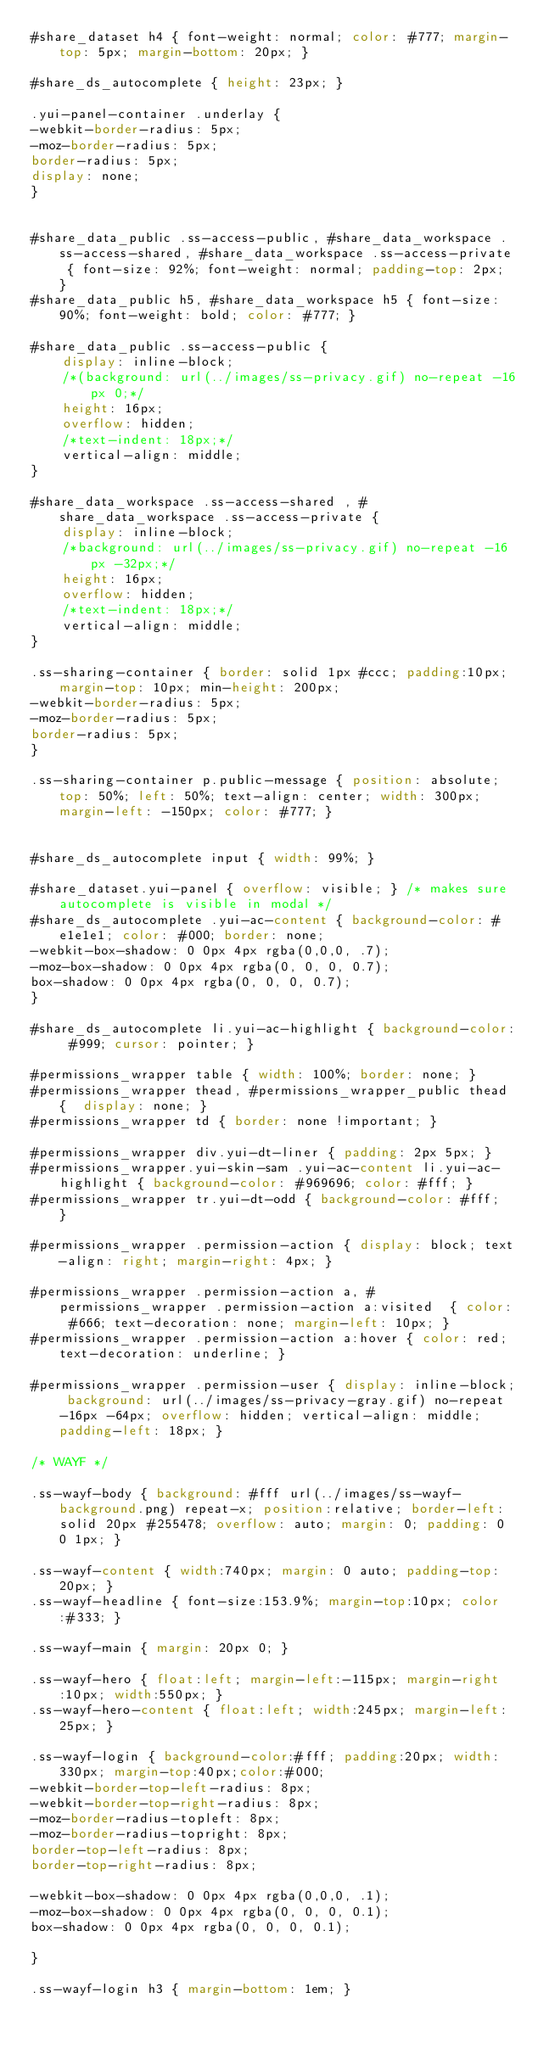<code> <loc_0><loc_0><loc_500><loc_500><_CSS_>#share_dataset h4 { font-weight: normal; color: #777; margin-top: 5px; margin-bottom: 20px; } 

#share_ds_autocomplete { height: 23px; }

.yui-panel-container .underlay {
-webkit-border-radius: 5px;
-moz-border-radius: 5px;
border-radius: 5px;
display: none;
}


#share_data_public .ss-access-public, #share_data_workspace .ss-access-shared, #share_data_workspace .ss-access-private { font-size: 92%; font-weight: normal; padding-top: 2px; }
#share_data_public h5, #share_data_workspace h5 { font-size: 90%; font-weight: bold; color: #777; }

#share_data_public .ss-access-public { 
    display: inline-block; 
    /*(background: url(../images/ss-privacy.gif) no-repeat -16px 0;*/
    height: 16px; 
    overflow: hidden; 
    /*text-indent: 18px;*/
    vertical-align: middle; 
}

#share_data_workspace .ss-access-shared , #share_data_workspace .ss-access-private { 
    display: inline-block; 
    /*background: url(../images/ss-privacy.gif) no-repeat -16px -32px;*/
    height: 16px; 
    overflow: hidden; 
    /*text-indent: 18px;*/
    vertical-align: middle; 
} 

.ss-sharing-container { border: solid 1px #ccc; padding:10px; margin-top: 10px; min-height: 200px;
-webkit-border-radius: 5px;
-moz-border-radius: 5px;
border-radius: 5px;
}

.ss-sharing-container p.public-message { position: absolute; top: 50%; left: 50%; text-align: center; width: 300px; margin-left: -150px; color: #777; }


#share_ds_autocomplete input { width: 99%; }

#share_dataset.yui-panel { overflow: visible; } /* makes sure autocomplete is visible in modal */
#share_ds_autocomplete .yui-ac-content { background-color: #e1e1e1; color: #000; border: none; 
-webkit-box-shadow: 0 0px 4px rgba(0,0,0, .7);
-moz-box-shadow: 0 0px 4px rgba(0, 0, 0, 0.7);
box-shadow: 0 0px 4px rgba(0, 0, 0, 0.7);
}

#share_ds_autocomplete li.yui-ac-highlight { background-color: #999; cursor: pointer; }

#permissions_wrapper table { width: 100%; border: none; }
#permissions_wrapper thead, #permissions_wrapper_public thead {  display: none; }
#permissions_wrapper td { border: none !important; } 

#permissions_wrapper div.yui-dt-liner { padding: 2px 5px; }
#permissions_wrapper.yui-skin-sam .yui-ac-content li.yui-ac-highlight { background-color: #969696; color: #fff; }
#permissions_wrapper tr.yui-dt-odd { background-color: #fff;  }

#permissions_wrapper .permission-action { display: block; text-align: right; margin-right: 4px; }

#permissions_wrapper .permission-action a, #permissions_wrapper .permission-action a:visited  { color: #666; text-decoration: none; margin-left: 10px; }
#permissions_wrapper .permission-action a:hover { color: red; text-decoration: underline; }

#permissions_wrapper .permission-user { display: inline-block; background: url(../images/ss-privacy-gray.gif) no-repeat -16px -64px; overflow: hidden; vertical-align: middle; padding-left: 18px; }

/* WAYF */

.ss-wayf-body { background: #fff url(../images/ss-wayf-background.png) repeat-x; position:relative; border-left: solid 20px #255478; overflow: auto; margin: 0; padding: 0 0 1px; }

.ss-wayf-content { width:740px; margin: 0 auto; padding-top: 20px; }
.ss-wayf-headline { font-size:153.9%; margin-top:10px; color:#333; }

.ss-wayf-main { margin: 20px 0; }

.ss-wayf-hero { float:left; margin-left:-115px; margin-right:10px; width:550px; }
.ss-wayf-hero-content { float:left; width:245px; margin-left: 25px; }

.ss-wayf-login { background-color:#fff; padding:20px; width: 330px; margin-top:40px;color:#000; 
-webkit-border-top-left-radius: 8px;
-webkit-border-top-right-radius: 8px;
-moz-border-radius-topleft: 8px;
-moz-border-radius-topright: 8px;
border-top-left-radius: 8px;
border-top-right-radius: 8px;

-webkit-box-shadow: 0 0px 4px rgba(0,0,0, .1);
-moz-box-shadow: 0 0px 4px rgba(0, 0, 0, 0.1);
box-shadow: 0 0px 4px rgba(0, 0, 0, 0.1);

}

.ss-wayf-login h3 { margin-bottom: 1em; }</code> 